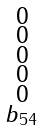<formula> <loc_0><loc_0><loc_500><loc_500>\begin{smallmatrix} 0 \\ 0 \\ 0 \\ 0 \\ 0 \\ b _ { 5 4 } \\ \end{smallmatrix}</formula> 